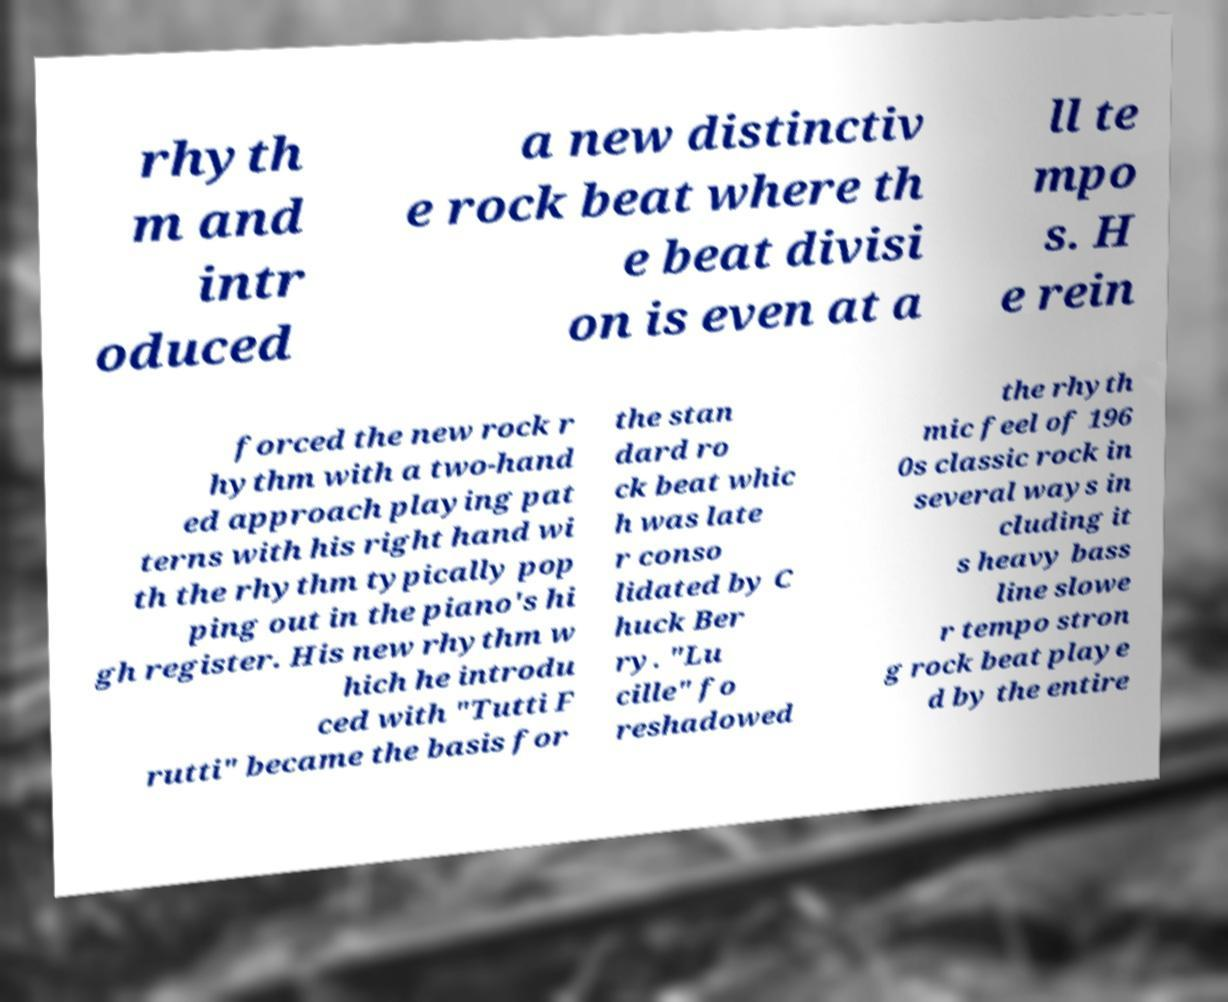Can you accurately transcribe the text from the provided image for me? rhyth m and intr oduced a new distinctiv e rock beat where th e beat divisi on is even at a ll te mpo s. H e rein forced the new rock r hythm with a two-hand ed approach playing pat terns with his right hand wi th the rhythm typically pop ping out in the piano's hi gh register. His new rhythm w hich he introdu ced with "Tutti F rutti" became the basis for the stan dard ro ck beat whic h was late r conso lidated by C huck Ber ry. "Lu cille" fo reshadowed the rhyth mic feel of 196 0s classic rock in several ways in cluding it s heavy bass line slowe r tempo stron g rock beat playe d by the entire 